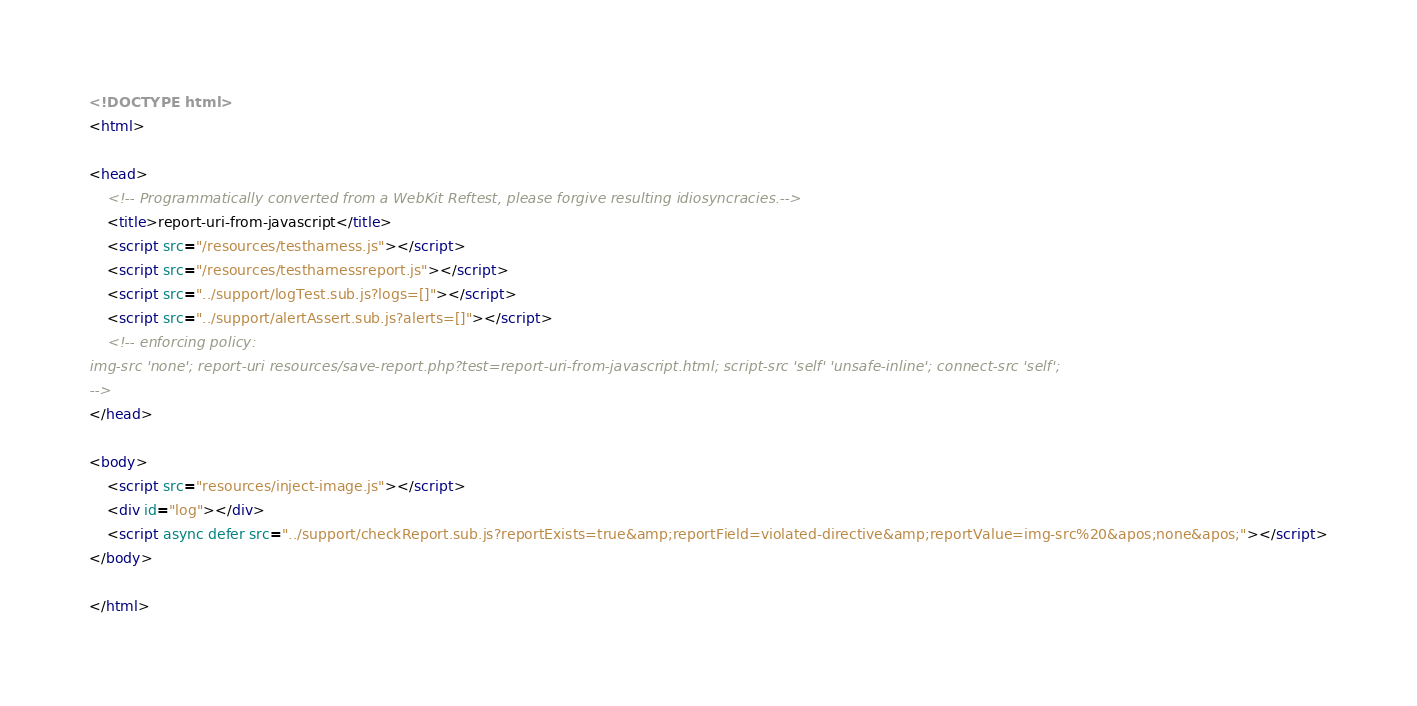Convert code to text. <code><loc_0><loc_0><loc_500><loc_500><_HTML_><!DOCTYPE html>
<html>

<head>
    <!-- Programmatically converted from a WebKit Reftest, please forgive resulting idiosyncracies.-->
    <title>report-uri-from-javascript</title>
    <script src="/resources/testharness.js"></script>
    <script src="/resources/testharnessreport.js"></script>
    <script src="../support/logTest.sub.js?logs=[]"></script>
    <script src="../support/alertAssert.sub.js?alerts=[]"></script>
    <!-- enforcing policy:
img-src 'none'; report-uri resources/save-report.php?test=report-uri-from-javascript.html; script-src 'self' 'unsafe-inline'; connect-src 'self';
-->
</head>

<body>
    <script src="resources/inject-image.js"></script>
    <div id="log"></div>
    <script async defer src="../support/checkReport.sub.js?reportExists=true&amp;reportField=violated-directive&amp;reportValue=img-src%20&apos;none&apos;"></script>
</body>

</html>
</code> 